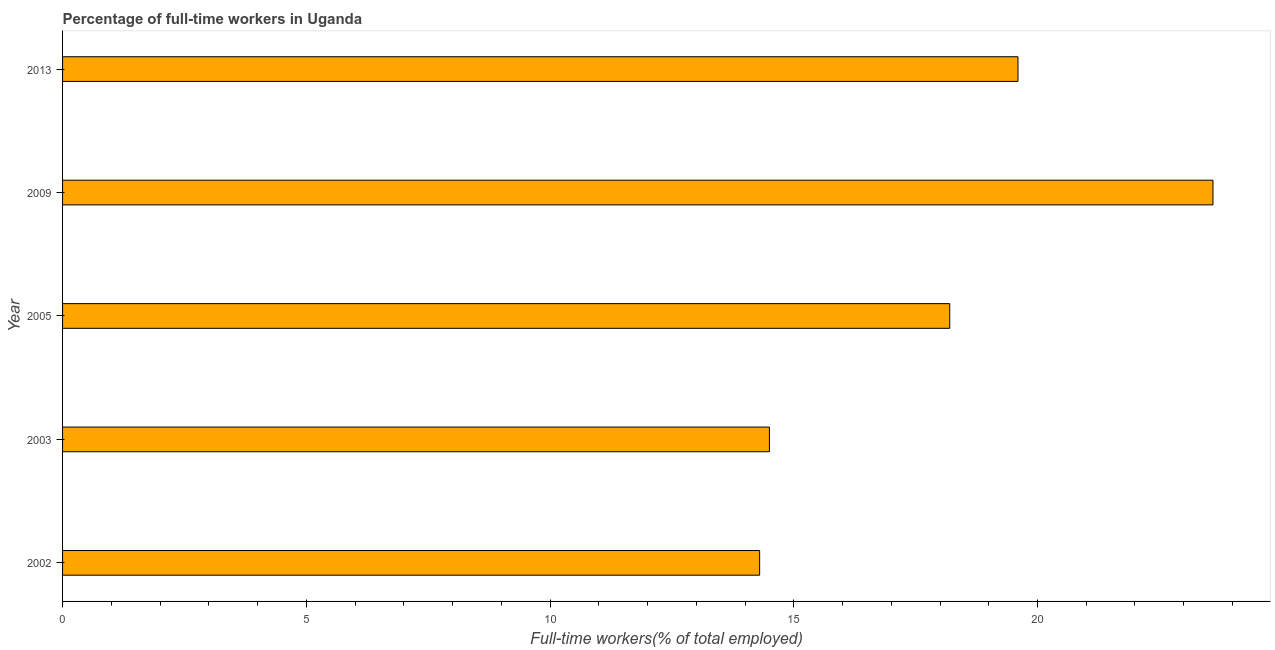Does the graph contain grids?
Your response must be concise. No. What is the title of the graph?
Offer a very short reply. Percentage of full-time workers in Uganda. What is the label or title of the X-axis?
Offer a terse response. Full-time workers(% of total employed). What is the label or title of the Y-axis?
Your response must be concise. Year. What is the percentage of full-time workers in 2002?
Offer a terse response. 14.3. Across all years, what is the maximum percentage of full-time workers?
Provide a short and direct response. 23.6. Across all years, what is the minimum percentage of full-time workers?
Provide a succinct answer. 14.3. In which year was the percentage of full-time workers maximum?
Keep it short and to the point. 2009. In which year was the percentage of full-time workers minimum?
Your response must be concise. 2002. What is the sum of the percentage of full-time workers?
Ensure brevity in your answer.  90.2. What is the difference between the percentage of full-time workers in 2002 and 2009?
Your response must be concise. -9.3. What is the average percentage of full-time workers per year?
Make the answer very short. 18.04. What is the median percentage of full-time workers?
Your response must be concise. 18.2. In how many years, is the percentage of full-time workers greater than 12 %?
Offer a terse response. 5. What is the ratio of the percentage of full-time workers in 2003 to that in 2009?
Ensure brevity in your answer.  0.61. Is the percentage of full-time workers in 2003 less than that in 2013?
Make the answer very short. Yes. Is the difference between the percentage of full-time workers in 2009 and 2013 greater than the difference between any two years?
Your answer should be compact. No. Is the sum of the percentage of full-time workers in 2003 and 2013 greater than the maximum percentage of full-time workers across all years?
Ensure brevity in your answer.  Yes. What is the difference between the highest and the lowest percentage of full-time workers?
Your answer should be very brief. 9.3. How many bars are there?
Ensure brevity in your answer.  5. How many years are there in the graph?
Your answer should be compact. 5. Are the values on the major ticks of X-axis written in scientific E-notation?
Offer a terse response. No. What is the Full-time workers(% of total employed) in 2002?
Offer a terse response. 14.3. What is the Full-time workers(% of total employed) in 2005?
Your response must be concise. 18.2. What is the Full-time workers(% of total employed) in 2009?
Provide a short and direct response. 23.6. What is the Full-time workers(% of total employed) of 2013?
Keep it short and to the point. 19.6. What is the difference between the Full-time workers(% of total employed) in 2002 and 2003?
Offer a terse response. -0.2. What is the difference between the Full-time workers(% of total employed) in 2003 and 2005?
Offer a very short reply. -3.7. What is the difference between the Full-time workers(% of total employed) in 2003 and 2009?
Provide a succinct answer. -9.1. What is the difference between the Full-time workers(% of total employed) in 2009 and 2013?
Give a very brief answer. 4. What is the ratio of the Full-time workers(% of total employed) in 2002 to that in 2005?
Give a very brief answer. 0.79. What is the ratio of the Full-time workers(% of total employed) in 2002 to that in 2009?
Offer a very short reply. 0.61. What is the ratio of the Full-time workers(% of total employed) in 2002 to that in 2013?
Your answer should be compact. 0.73. What is the ratio of the Full-time workers(% of total employed) in 2003 to that in 2005?
Your response must be concise. 0.8. What is the ratio of the Full-time workers(% of total employed) in 2003 to that in 2009?
Offer a terse response. 0.61. What is the ratio of the Full-time workers(% of total employed) in 2003 to that in 2013?
Offer a very short reply. 0.74. What is the ratio of the Full-time workers(% of total employed) in 2005 to that in 2009?
Keep it short and to the point. 0.77. What is the ratio of the Full-time workers(% of total employed) in 2005 to that in 2013?
Provide a succinct answer. 0.93. What is the ratio of the Full-time workers(% of total employed) in 2009 to that in 2013?
Keep it short and to the point. 1.2. 